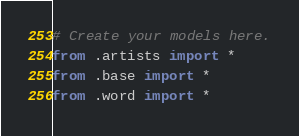<code> <loc_0><loc_0><loc_500><loc_500><_Python_># Create your models here.
from .artists import *
from .base import *
from .word import *
</code> 